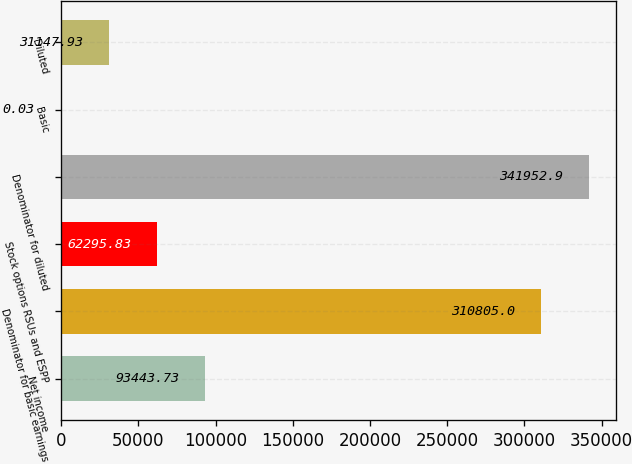<chart> <loc_0><loc_0><loc_500><loc_500><bar_chart><fcel>Net income<fcel>Denominator for basic earnings<fcel>Stock options RSUs and ESPP<fcel>Denominator for diluted<fcel>Basic<fcel>Diluted<nl><fcel>93443.7<fcel>310805<fcel>62295.8<fcel>341953<fcel>0.03<fcel>31147.9<nl></chart> 